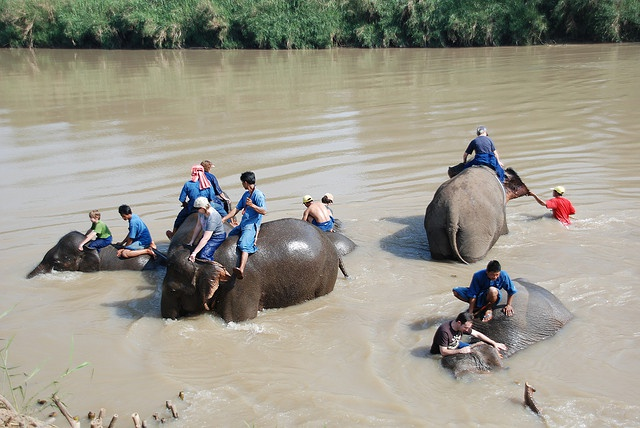Describe the objects in this image and their specific colors. I can see elephant in green, black, gray, and maroon tones, elephant in green, darkgray, black, and gray tones, elephant in green, darkgray, gray, and black tones, elephant in green, black, gray, and darkgray tones, and people in green, black, navy, maroon, and blue tones in this image. 